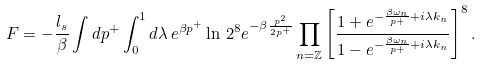<formula> <loc_0><loc_0><loc_500><loc_500>F = - \frac { l _ { s } } { \beta } \int d p ^ { + } \int _ { 0 } ^ { 1 } d \lambda \, e ^ { \beta p ^ { + } } \ln \, 2 ^ { 8 } e ^ { - \beta \frac { p ^ { 2 } } { 2 p ^ { + } } } \prod _ { n = { \mathbb { Z } } } \left [ \frac { 1 + e ^ { - \frac { \beta \omega _ { n } } { p + } + i \lambda k _ { n } } } { 1 - e ^ { - \frac { \beta \omega _ { n } } { p + } + i \lambda k _ { n } } } \right ] ^ { 8 } .</formula> 